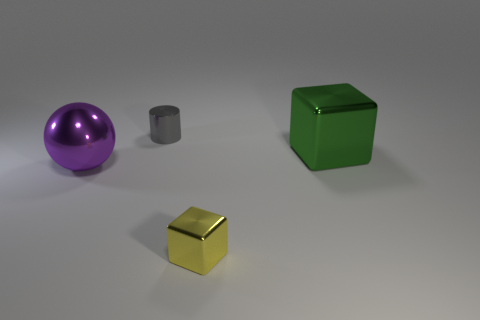There is a big object that is to the left of the tiny shiny thing in front of the tiny gray cylinder; how many tiny gray metallic things are to the left of it?
Offer a terse response. 0. Is the number of large gray rubber things greater than the number of big green shiny things?
Your answer should be very brief. No. How many gray shiny objects are there?
Offer a terse response. 1. What is the shape of the metallic object left of the tiny object on the left side of the metallic block in front of the large green object?
Make the answer very short. Sphere. Are there fewer cubes in front of the yellow metal thing than tiny objects behind the metallic cylinder?
Keep it short and to the point. No. There is a big metal object that is to the left of the tiny gray metallic object; is it the same shape as the small object that is in front of the gray object?
Your response must be concise. No. What shape is the large metal thing that is to the left of the metallic block that is left of the large green block?
Offer a very short reply. Sphere. Are there any tiny yellow cubes made of the same material as the green thing?
Make the answer very short. Yes. What material is the large object left of the tiny yellow metal object?
Make the answer very short. Metal. What is the material of the yellow thing?
Offer a terse response. Metal. 